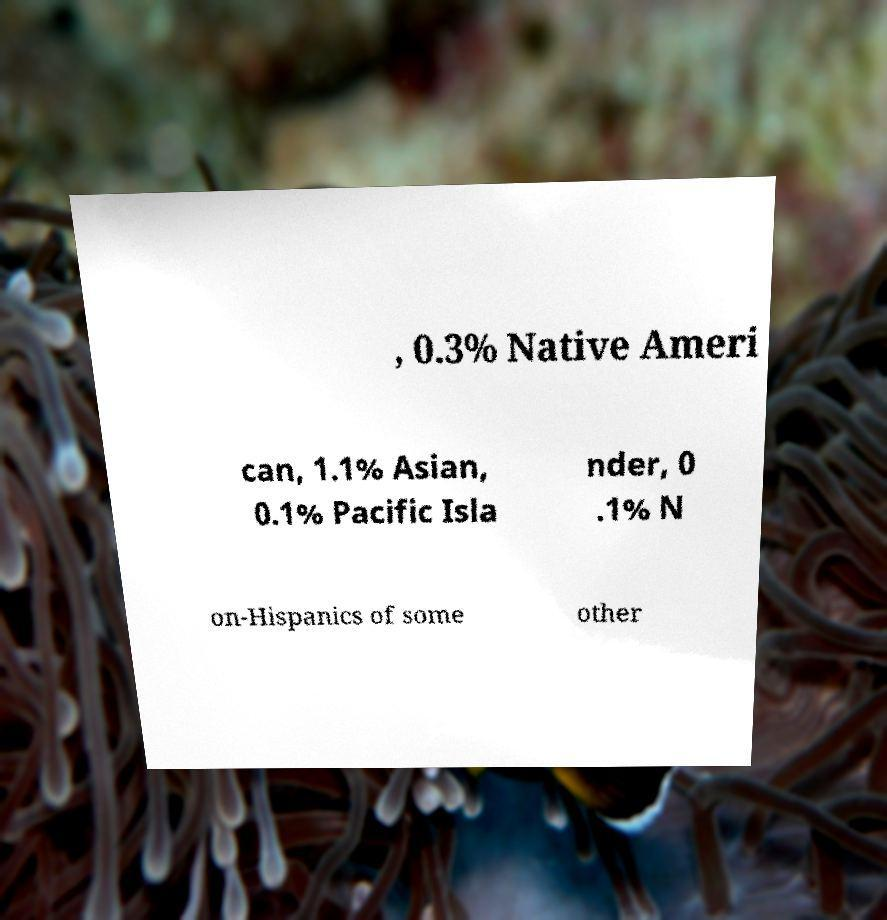I need the written content from this picture converted into text. Can you do that? , 0.3% Native Ameri can, 1.1% Asian, 0.1% Pacific Isla nder, 0 .1% N on-Hispanics of some other 